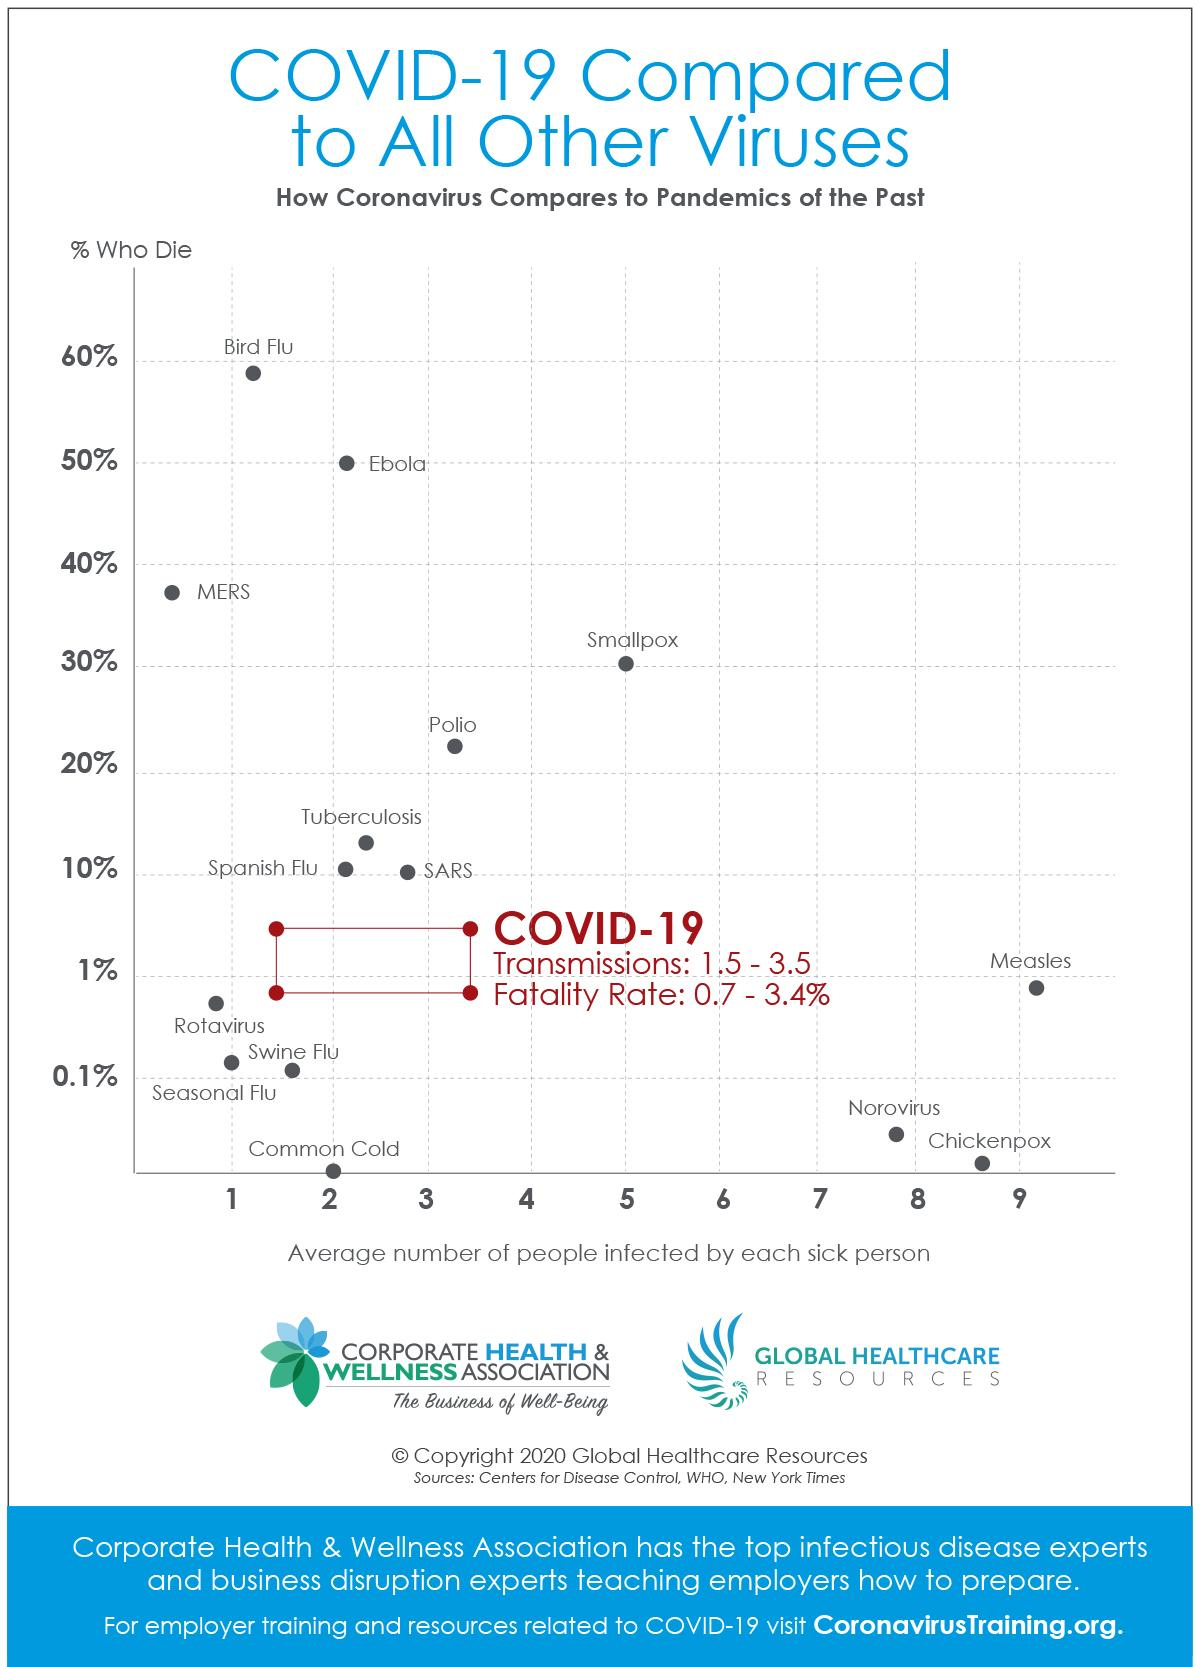Point out several critical features in this image. Diseases that result in more than 50% of deaths include Ebola and the Bird Flu. According to the graph, Ebola is the second most deadly disease. According to the graph, Norovirus, Chickenpox, and Measles are the three most contagious diseases. The following diseases and viruses have a mortality rate of less than 0.1%, including the Common Cold, Norovirus, and Chickenpox. The disease with a fatality rate of 0% is the Common Cold. 